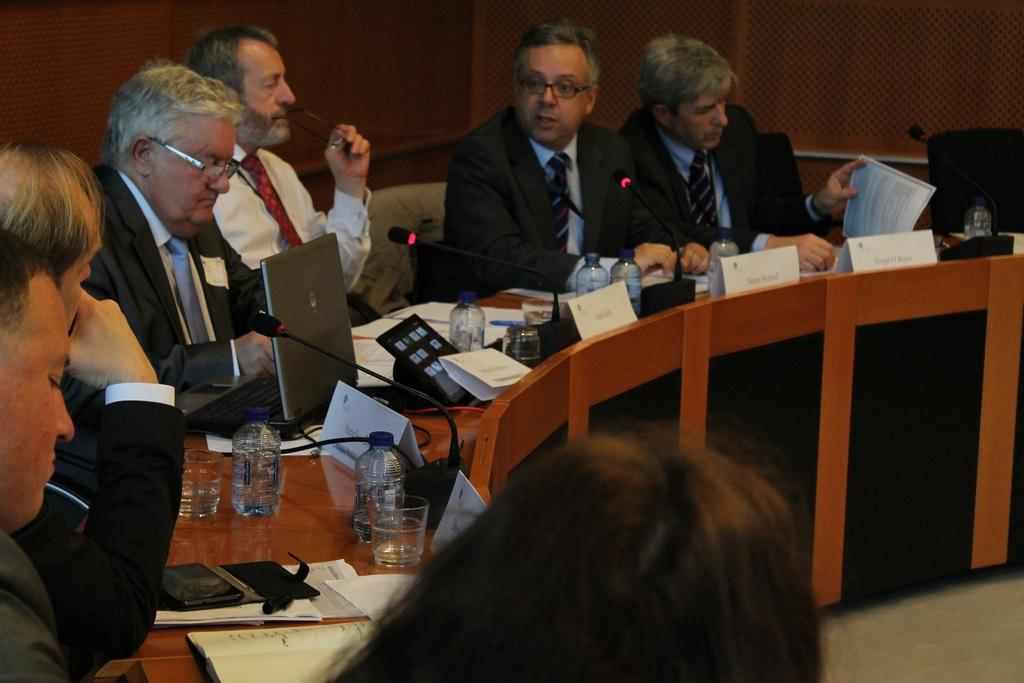What are the men in the image doing? The men are sitting on chairs in the image. What is in front of the men? The men are in front of a table. What can be seen on the table? There are glasses, bottles, a laptop, microphones, and other objects on the table. Can you see any cracks in the laptop screen in the image? There is: There is no indication of any cracks in the laptop screen in the image. 